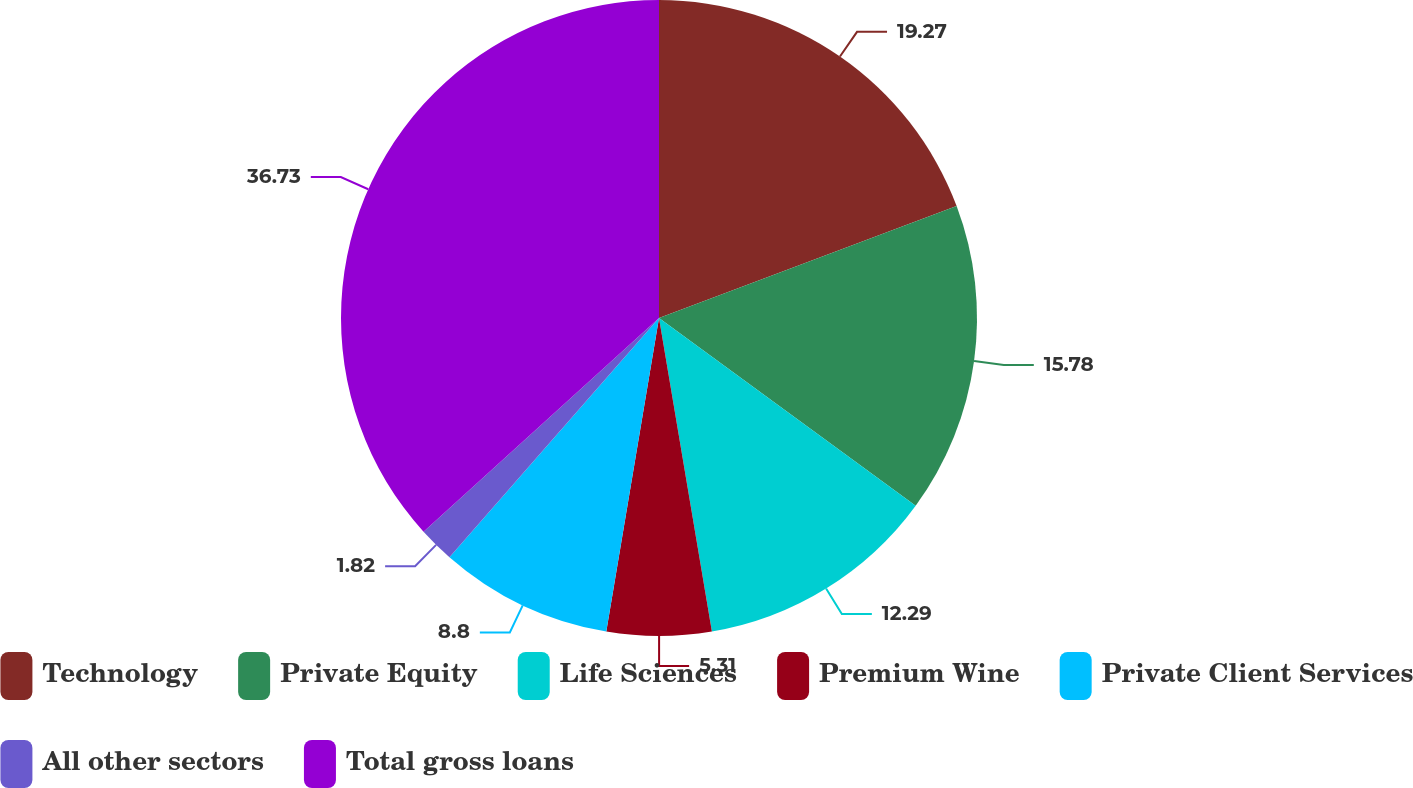<chart> <loc_0><loc_0><loc_500><loc_500><pie_chart><fcel>Technology<fcel>Private Equity<fcel>Life Sciences<fcel>Premium Wine<fcel>Private Client Services<fcel>All other sectors<fcel>Total gross loans<nl><fcel>19.27%<fcel>15.78%<fcel>12.29%<fcel>5.31%<fcel>8.8%<fcel>1.82%<fcel>36.73%<nl></chart> 